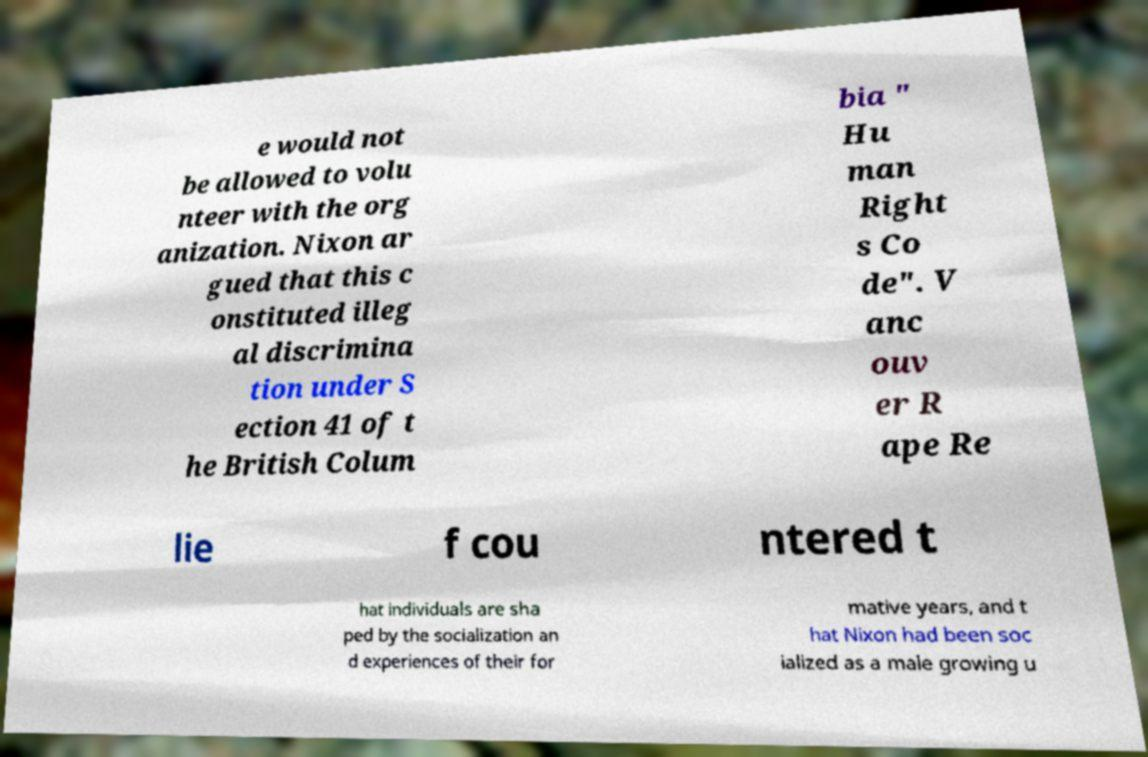For documentation purposes, I need the text within this image transcribed. Could you provide that? e would not be allowed to volu nteer with the org anization. Nixon ar gued that this c onstituted illeg al discrimina tion under S ection 41 of t he British Colum bia " Hu man Right s Co de". V anc ouv er R ape Re lie f cou ntered t hat individuals are sha ped by the socialization an d experiences of their for mative years, and t hat Nixon had been soc ialized as a male growing u 